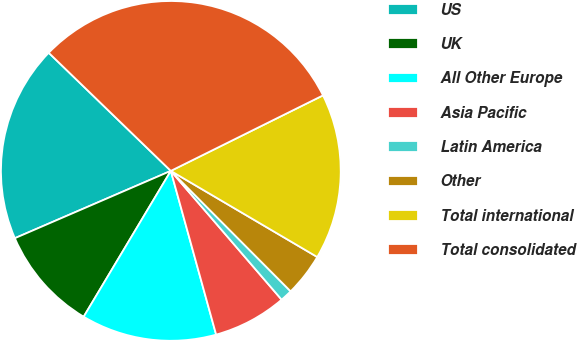<chart> <loc_0><loc_0><loc_500><loc_500><pie_chart><fcel>US<fcel>UK<fcel>All Other Europe<fcel>Asia Pacific<fcel>Latin America<fcel>Other<fcel>Total international<fcel>Total consolidated<nl><fcel>18.72%<fcel>9.94%<fcel>12.87%<fcel>7.01%<fcel>1.15%<fcel>4.08%<fcel>15.79%<fcel>30.43%<nl></chart> 